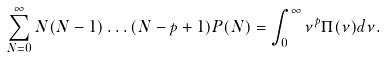Convert formula to latex. <formula><loc_0><loc_0><loc_500><loc_500>\sum _ { N = 0 } ^ { \infty } N ( N - 1 ) \dots ( N - p + 1 ) P ( N ) = \int _ { 0 } ^ { \infty } \nu ^ { p } \Pi ( \nu ) d \nu .</formula> 